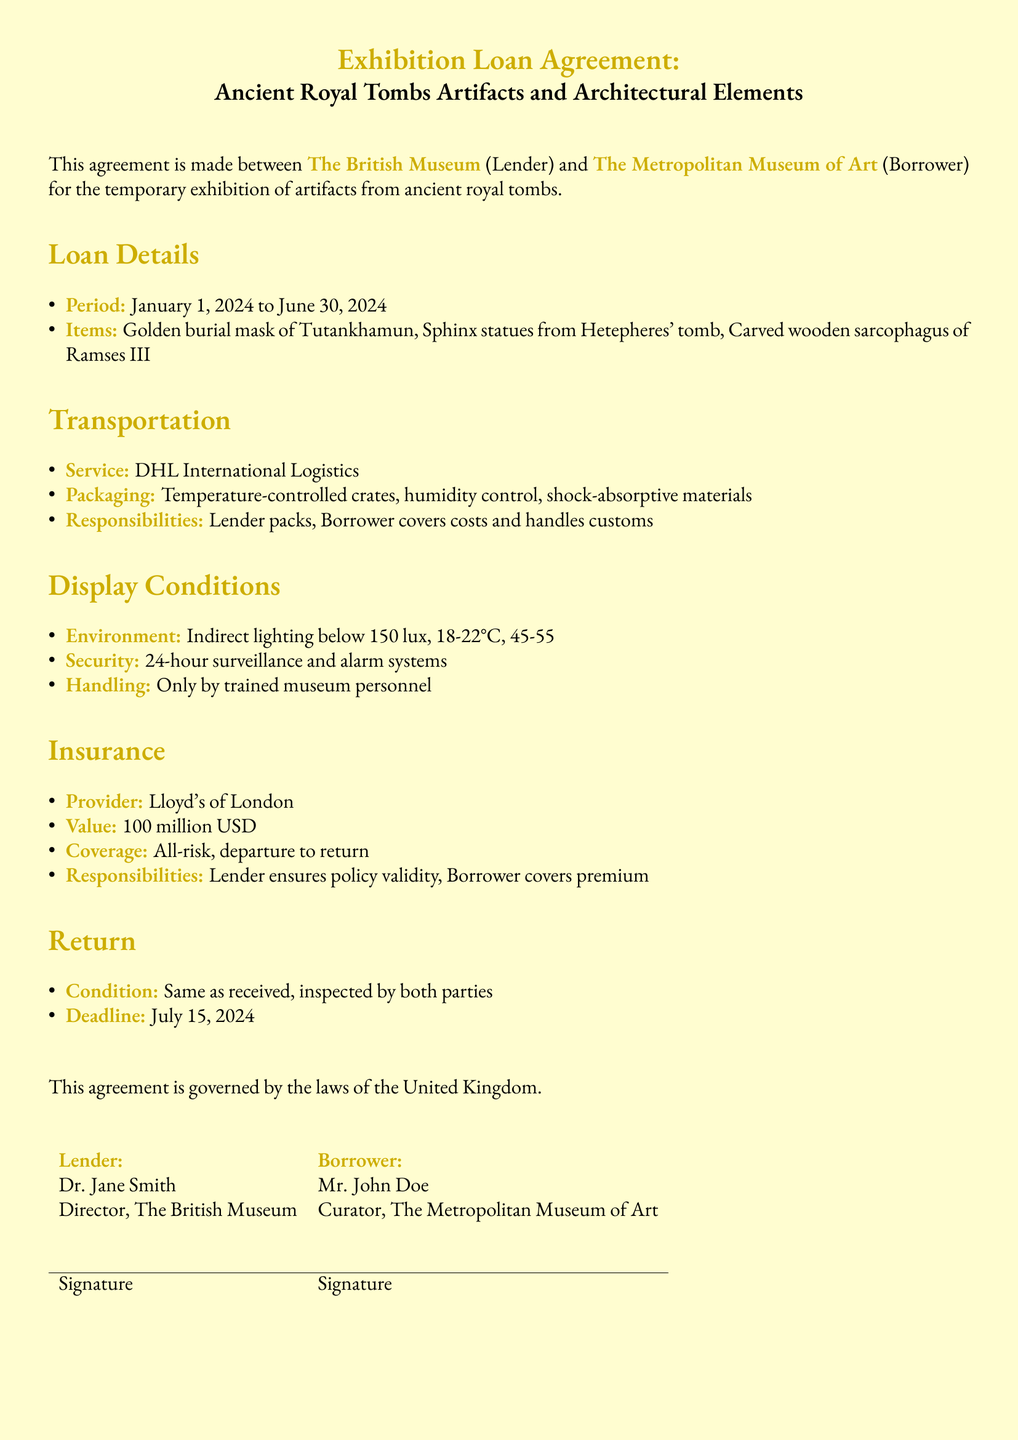What is the loan period? The loan period is specified in the document, listing the start and end dates.
Answer: January 1, 2024 to June 30, 2024 Who is the lender? The document identifies the parties involved in the contract, specifically the lender's name and title.
Answer: The British Museum What items are included in the loan? The document lists specific artifacts and architectural elements that are part of the agreement.
Answer: Golden burial mask of Tutankhamun, Sphinx statues from Hetepheres' tomb, Carved wooden sarcophagus of Ramses III What is the insurance value? The insurance value is stated in the document and represents the total coverage amount.
Answer: 100 million USD What is the return deadline? The contract specifies a deadline for the artifacts to be returned, giving a clear date for compliance.
Answer: July 15, 2024 Who is responsible for covering the premium of the insurance? The responsibilities regarding insurance are outlined, including who handles the premium payment.
Answer: Borrower What packaging conditions are specified? The document outlines specific requirements for how the items must be packaged for transportation.
Answer: Temperature-controlled crates, humidity control, shock-absorptive materials What is required for display environmental conditions? The display conditions list the necessary environment specifications for the artifacts during the exhibition.
Answer: Indirect lighting below 150 lux, 18-22°C, 45-55% humidity What security measures are mentioned? The document specifies security protocols required for the artifacts during the exhibition period.
Answer: 24-hour surveillance and alarm systems 